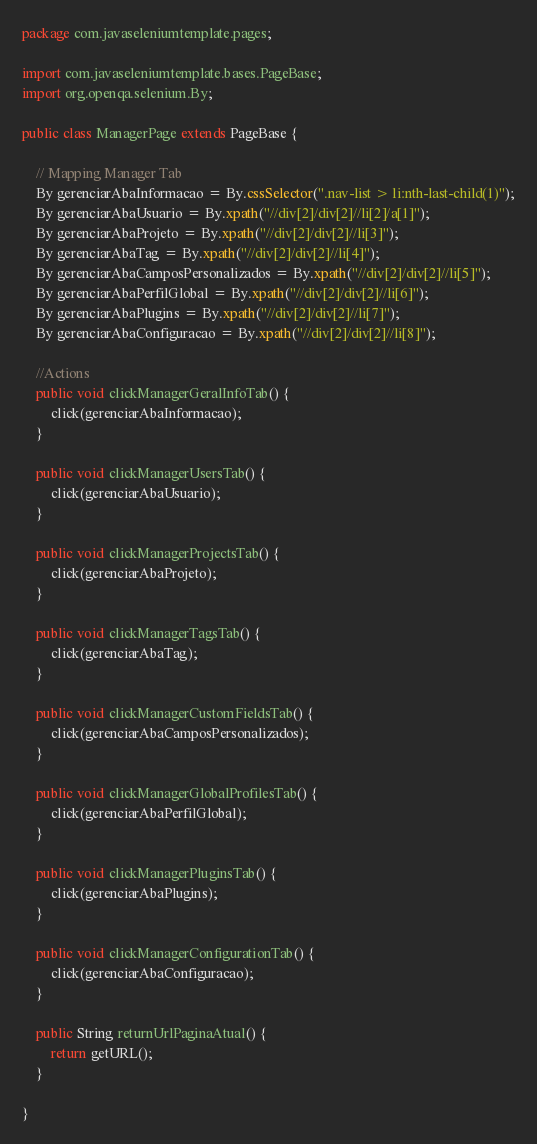Convert code to text. <code><loc_0><loc_0><loc_500><loc_500><_Java_>package com.javaseleniumtemplate.pages;

import com.javaseleniumtemplate.bases.PageBase;
import org.openqa.selenium.By;

public class ManagerPage extends PageBase {

    // Mapping Manager Tab
    By gerenciarAbaInformacao = By.cssSelector(".nav-list > li:nth-last-child(1)");
    By gerenciarAbaUsuario = By.xpath("//div[2]/div[2]//li[2]/a[1]");
    By gerenciarAbaProjeto = By.xpath("//div[2]/div[2]//li[3]");
    By gerenciarAbaTag = By.xpath("//div[2]/div[2]//li[4]");
    By gerenciarAbaCamposPersonalizados = By.xpath("//div[2]/div[2]//li[5]");
    By gerenciarAbaPerfilGlobal = By.xpath("//div[2]/div[2]//li[6]");
    By gerenciarAbaPlugins = By.xpath("//div[2]/div[2]//li[7]");
    By gerenciarAbaConfiguracao = By.xpath("//div[2]/div[2]//li[8]");

    //Actions
    public void clickManagerGeralInfoTab() {
        click(gerenciarAbaInformacao);
    }

    public void clickManagerUsersTab() {
        click(gerenciarAbaUsuario);
    }

    public void clickManagerProjectsTab() {
        click(gerenciarAbaProjeto);
    }

    public void clickManagerTagsTab() {
        click(gerenciarAbaTag);
    }

    public void clickManagerCustomFieldsTab() {
        click(gerenciarAbaCamposPersonalizados);
    }

    public void clickManagerGlobalProfilesTab() {
        click(gerenciarAbaPerfilGlobal);
    }

    public void clickManagerPluginsTab() {
        click(gerenciarAbaPlugins);
    }

    public void clickManagerConfigurationTab() {
        click(gerenciarAbaConfiguracao);
    }

    public String returnUrlPaginaAtual() {
        return getURL();
    }

}
</code> 